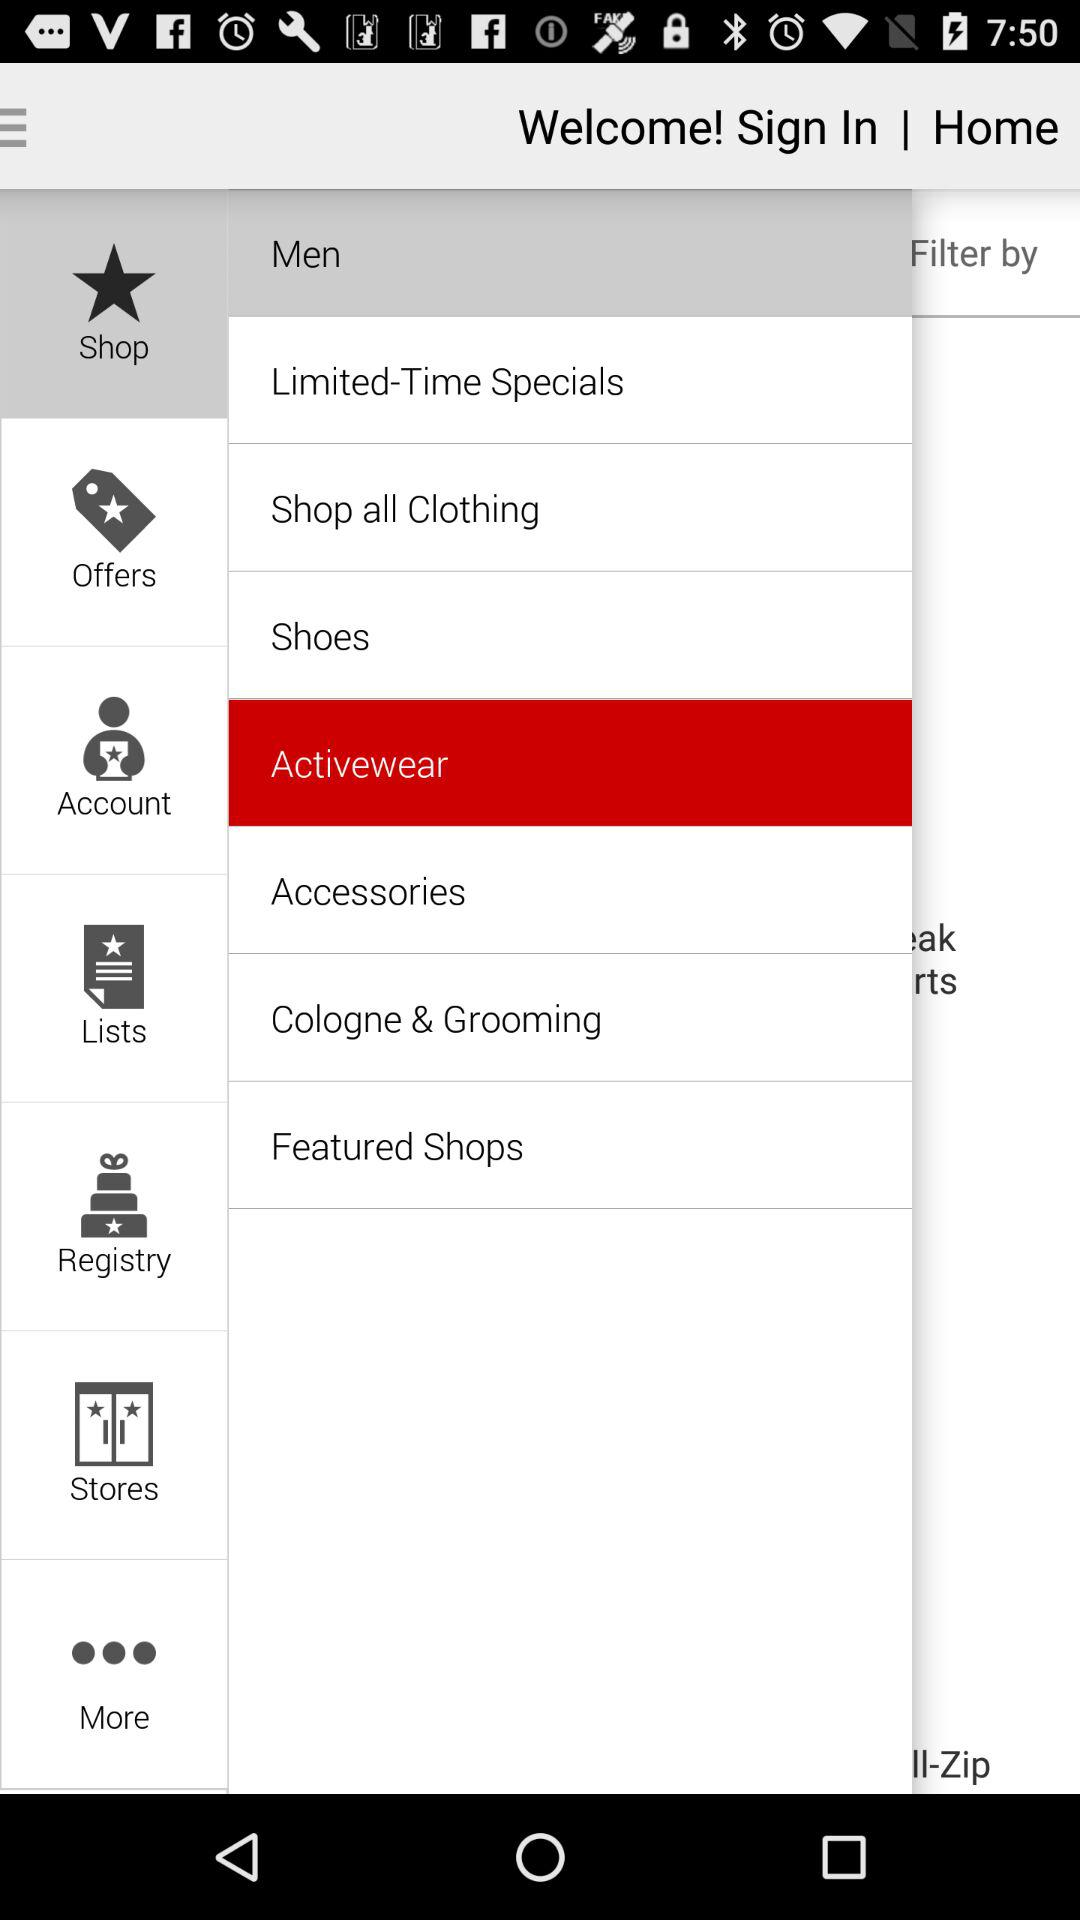Which option is selected in the men's category? The selected option is Activewear. 